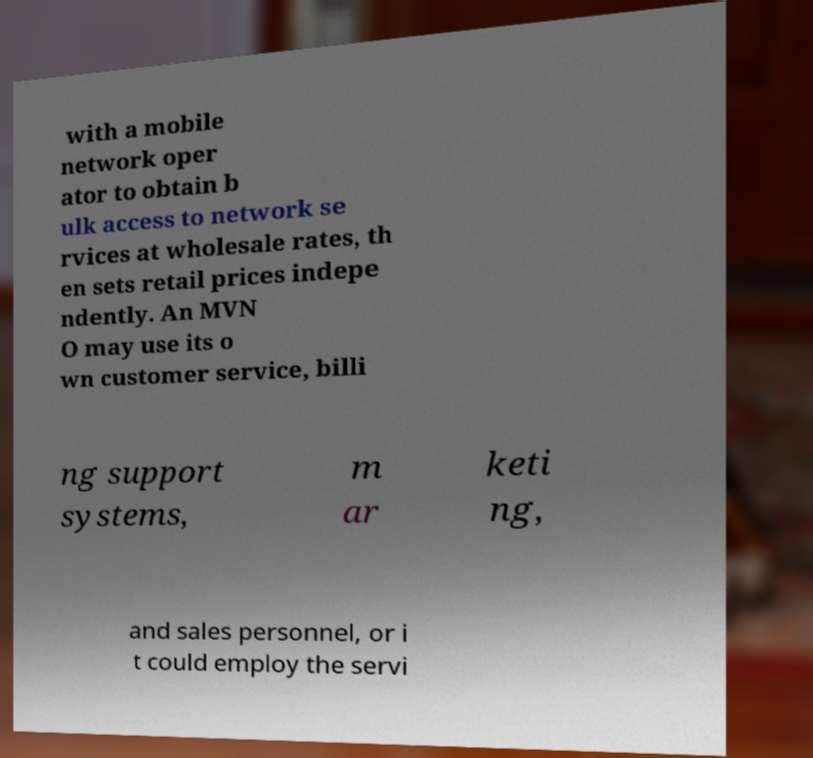Please identify and transcribe the text found in this image. with a mobile network oper ator to obtain b ulk access to network se rvices at wholesale rates, th en sets retail prices indepe ndently. An MVN O may use its o wn customer service, billi ng support systems, m ar keti ng, and sales personnel, or i t could employ the servi 